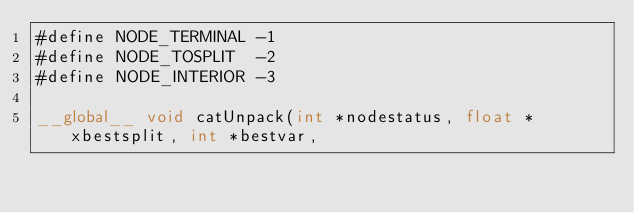<code> <loc_0><loc_0><loc_500><loc_500><_Cuda_>#define NODE_TERMINAL -1
#define NODE_TOSPLIT  -2
#define NODE_INTERIOR -3

__global__ void catUnpack(int *nodestatus, float *xbestsplit, int *bestvar,</code> 